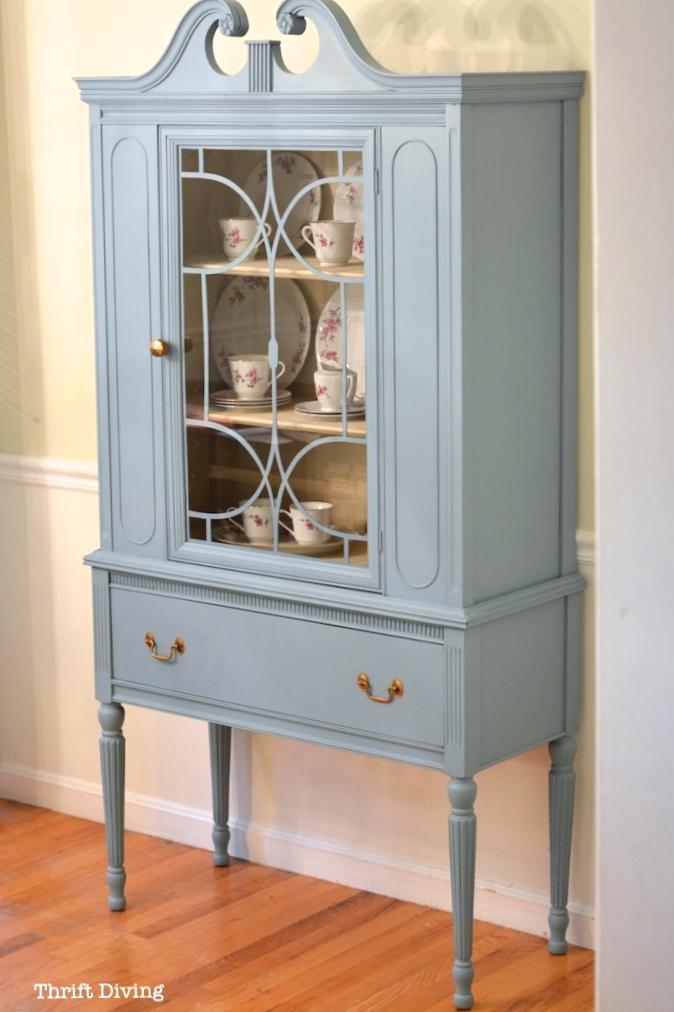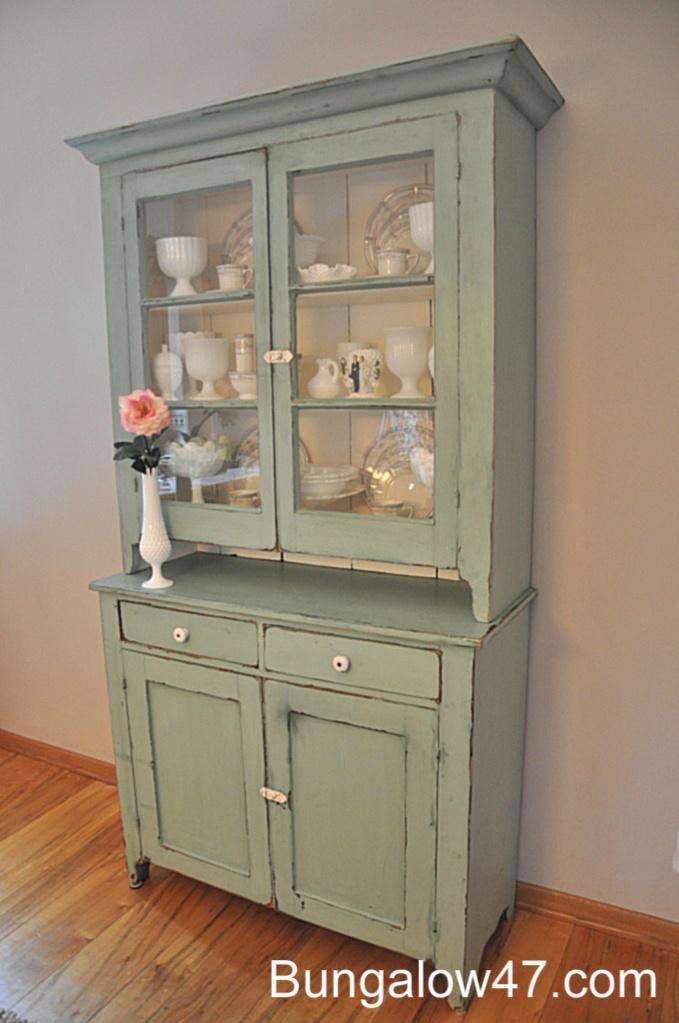The first image is the image on the left, the second image is the image on the right. For the images shown, is this caption "There is a flower in a vase." true? Answer yes or no. Yes. The first image is the image on the left, the second image is the image on the right. Evaluate the accuracy of this statement regarding the images: "A blue china cabinet sits against a wall with beadboard on the lower half.". Is it true? Answer yes or no. Yes. 